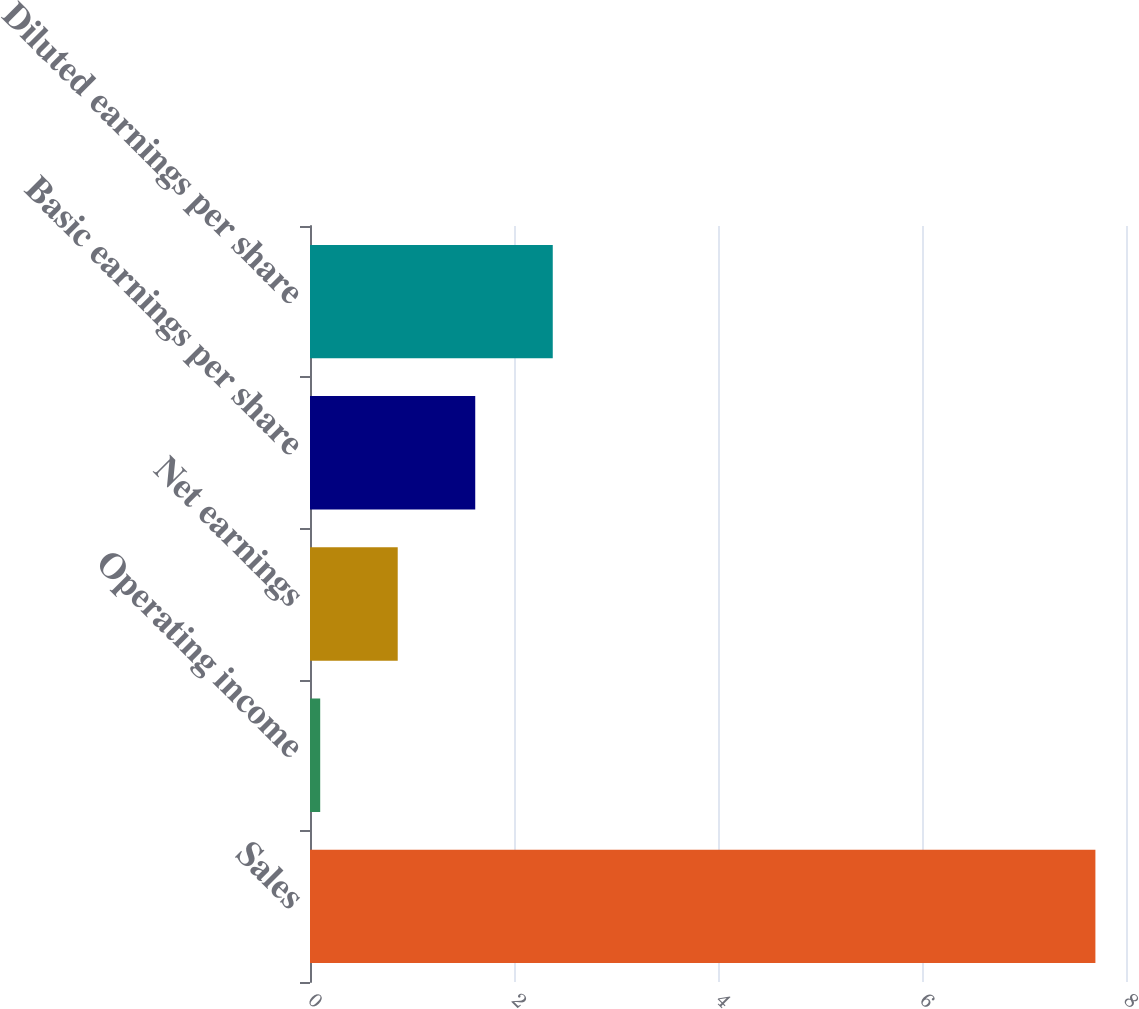Convert chart. <chart><loc_0><loc_0><loc_500><loc_500><bar_chart><fcel>Sales<fcel>Operating income<fcel>Net earnings<fcel>Basic earnings per share<fcel>Diluted earnings per share<nl><fcel>7.7<fcel>0.1<fcel>0.86<fcel>1.62<fcel>2.38<nl></chart> 